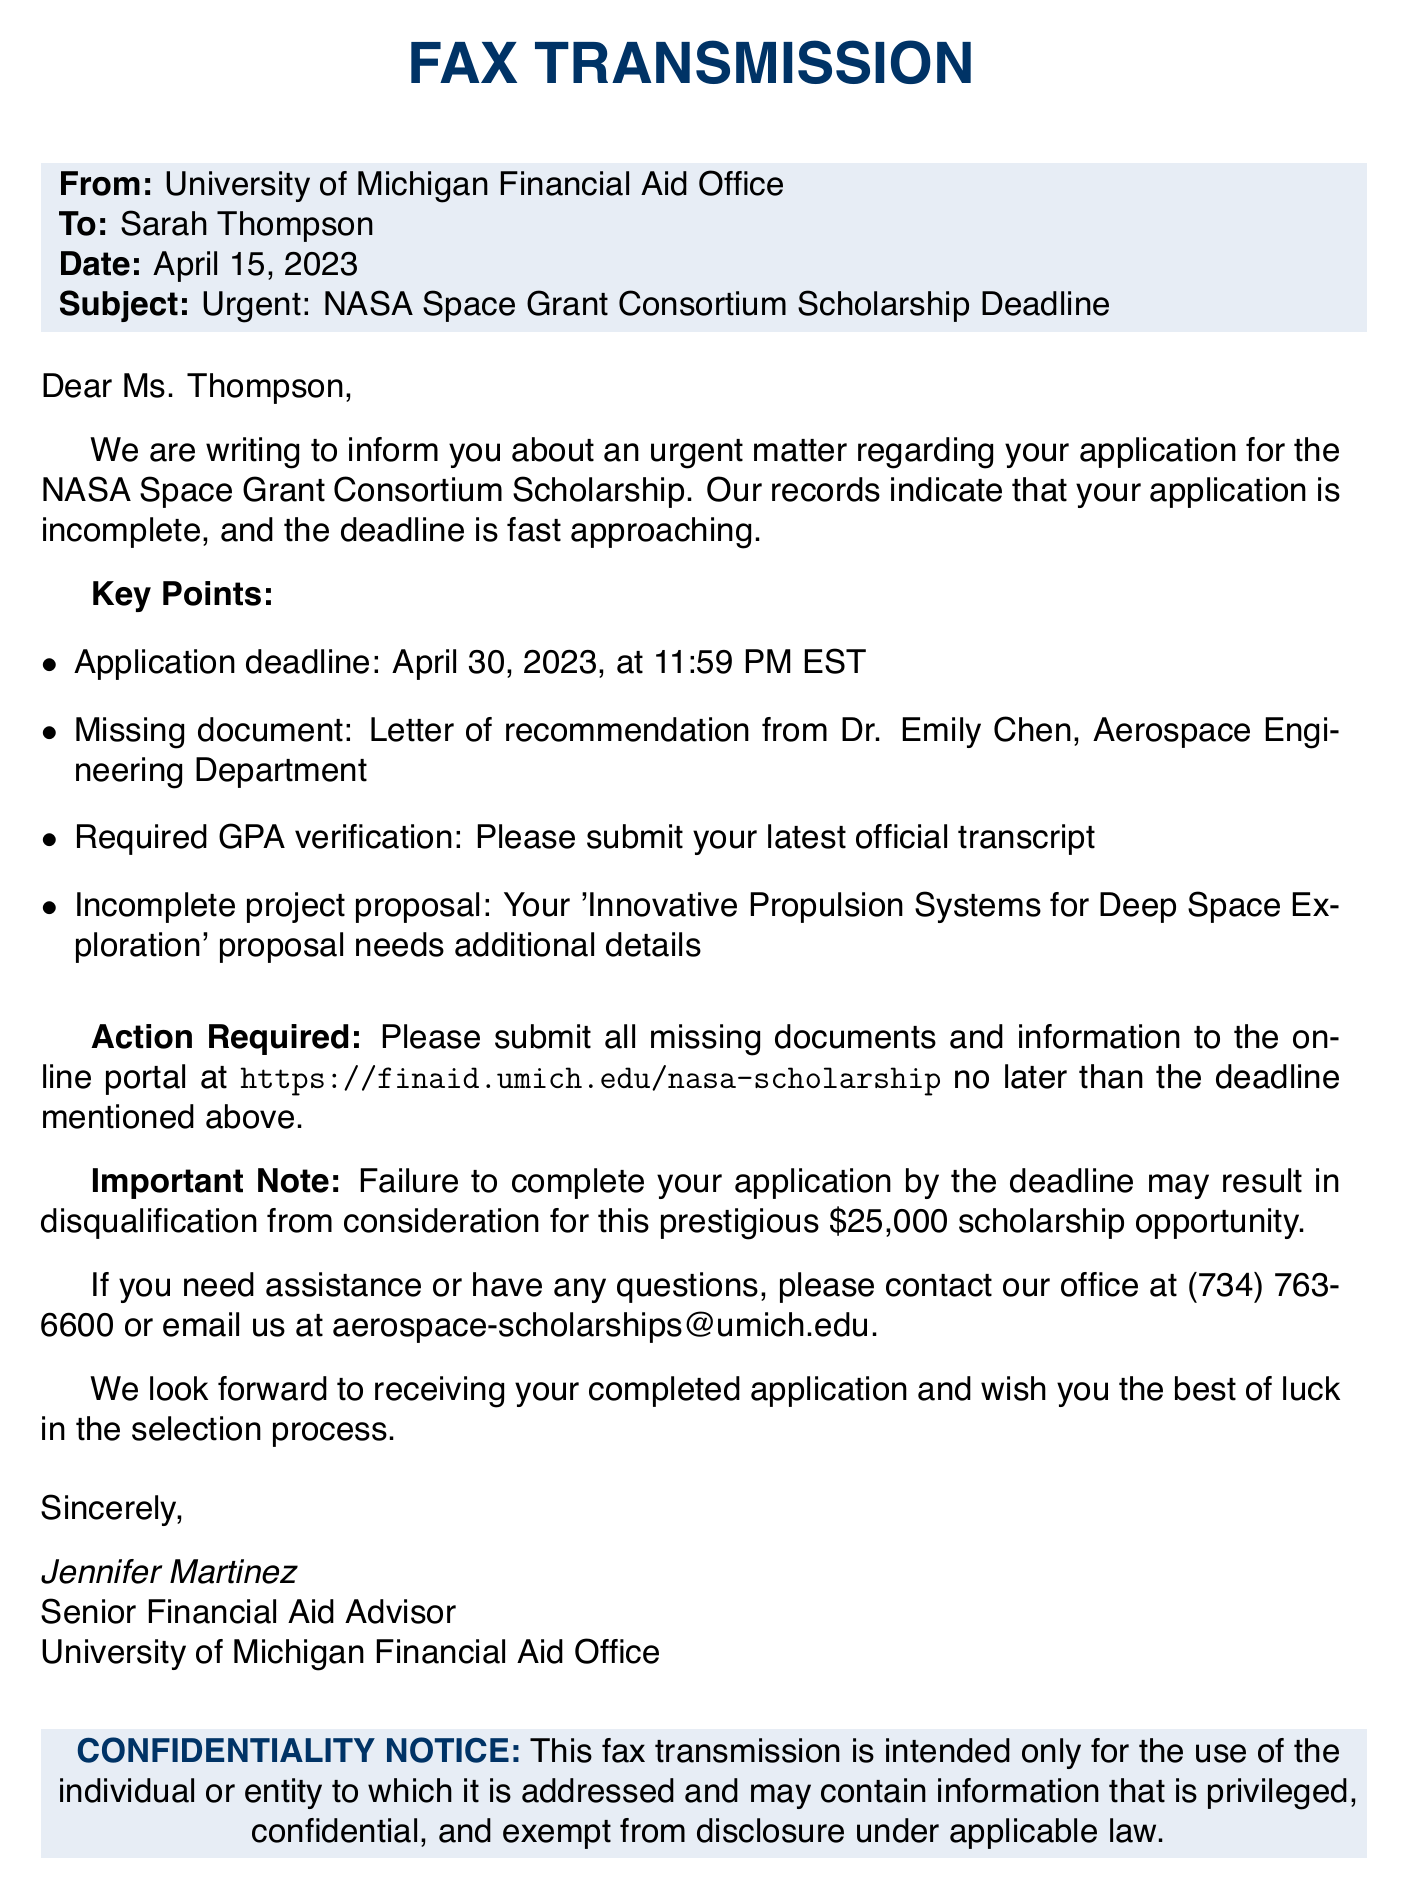What is the application deadline for the scholarship? The application deadline is specified in the document as April 30, 2023, at 11:59 PM EST.
Answer: April 30, 2023, at 11:59 PM EST Who is the missing document from? The document mentions that the missing document is a letter of recommendation from Dr. Emily Chen.
Answer: Dr. Emily Chen What is the scholarship amount? The document states that the scholarship opportunity is worth \$25,000.
Answer: $25,000 What does the incomplete project proposal need? The document specifies that the proposal needs additional details.
Answer: Additional details What should be submitted for GPA verification? The document requests the submission of the latest official transcript for GPA verification.
Answer: Latest official transcript What is the primary contact number for the financial aid office? The document provides the contact number as (734) 763-6600.
Answer: (734) 763-6600 What action is required from the applicant? The document states that the applicant must submit all missing documents and information to the online portal.
Answer: Submit all missing documents and information What is the purpose of this fax transmission? This fax transmission is an urgent request regarding the applicant's scholarship application.
Answer: Urgent request regarding scholarship application What is specified in the confidentiality notice? The confidentiality notice indicates that the fax may contain information that is privileged and confidential.
Answer: Privileged and confidential information 